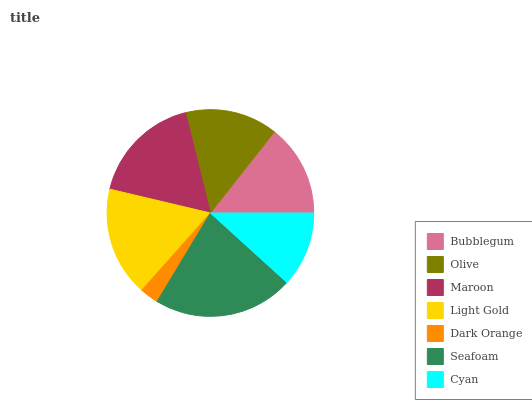Is Dark Orange the minimum?
Answer yes or no. Yes. Is Seafoam the maximum?
Answer yes or no. Yes. Is Olive the minimum?
Answer yes or no. No. Is Olive the maximum?
Answer yes or no. No. Is Olive greater than Bubblegum?
Answer yes or no. Yes. Is Bubblegum less than Olive?
Answer yes or no. Yes. Is Bubblegum greater than Olive?
Answer yes or no. No. Is Olive less than Bubblegum?
Answer yes or no. No. Is Olive the high median?
Answer yes or no. Yes. Is Olive the low median?
Answer yes or no. Yes. Is Dark Orange the high median?
Answer yes or no. No. Is Seafoam the low median?
Answer yes or no. No. 